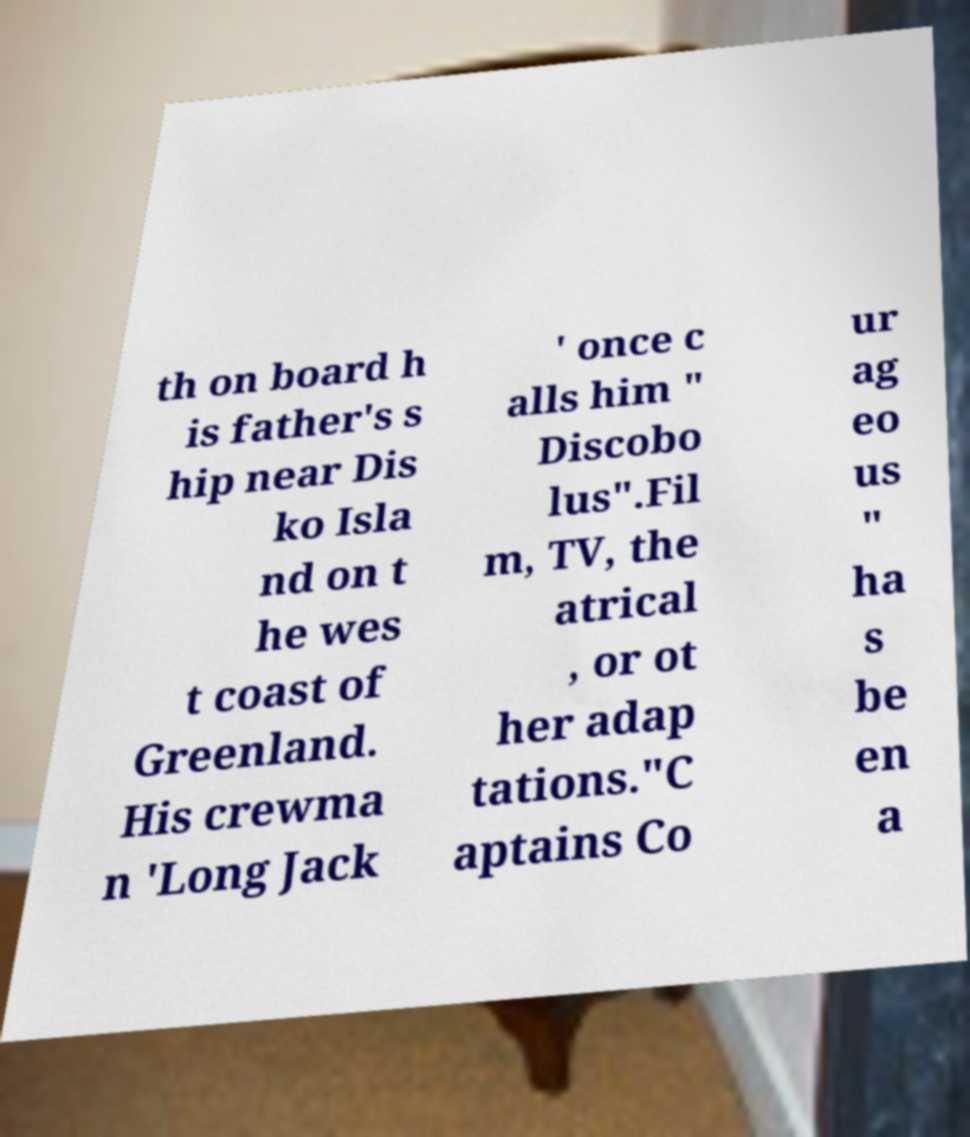Please identify and transcribe the text found in this image. th on board h is father's s hip near Dis ko Isla nd on t he wes t coast of Greenland. His crewma n 'Long Jack ' once c alls him " Discobo lus".Fil m, TV, the atrical , or ot her adap tations."C aptains Co ur ag eo us " ha s be en a 